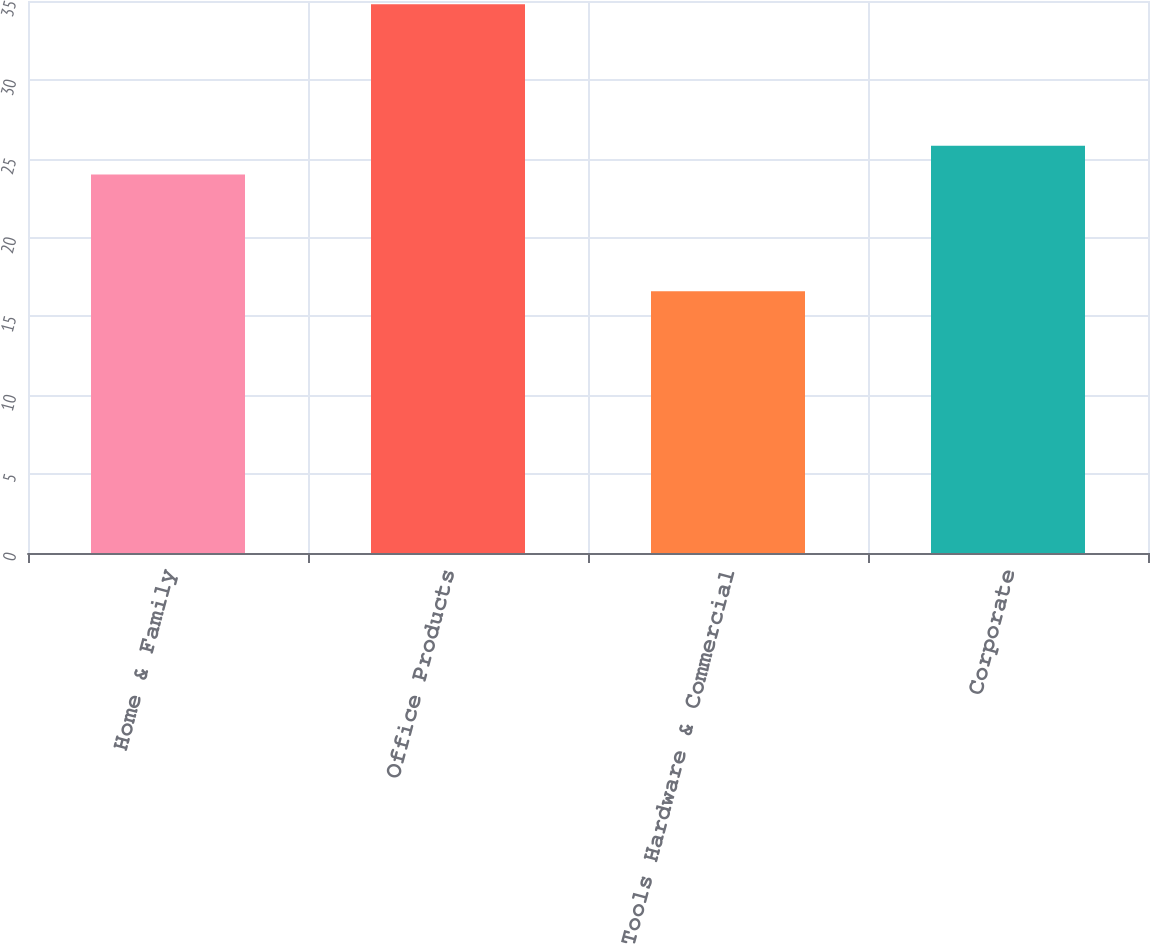Convert chart. <chart><loc_0><loc_0><loc_500><loc_500><bar_chart><fcel>Home & Family<fcel>Office Products<fcel>Tools Hardware & Commercial<fcel>Corporate<nl><fcel>24<fcel>34.8<fcel>16.6<fcel>25.82<nl></chart> 